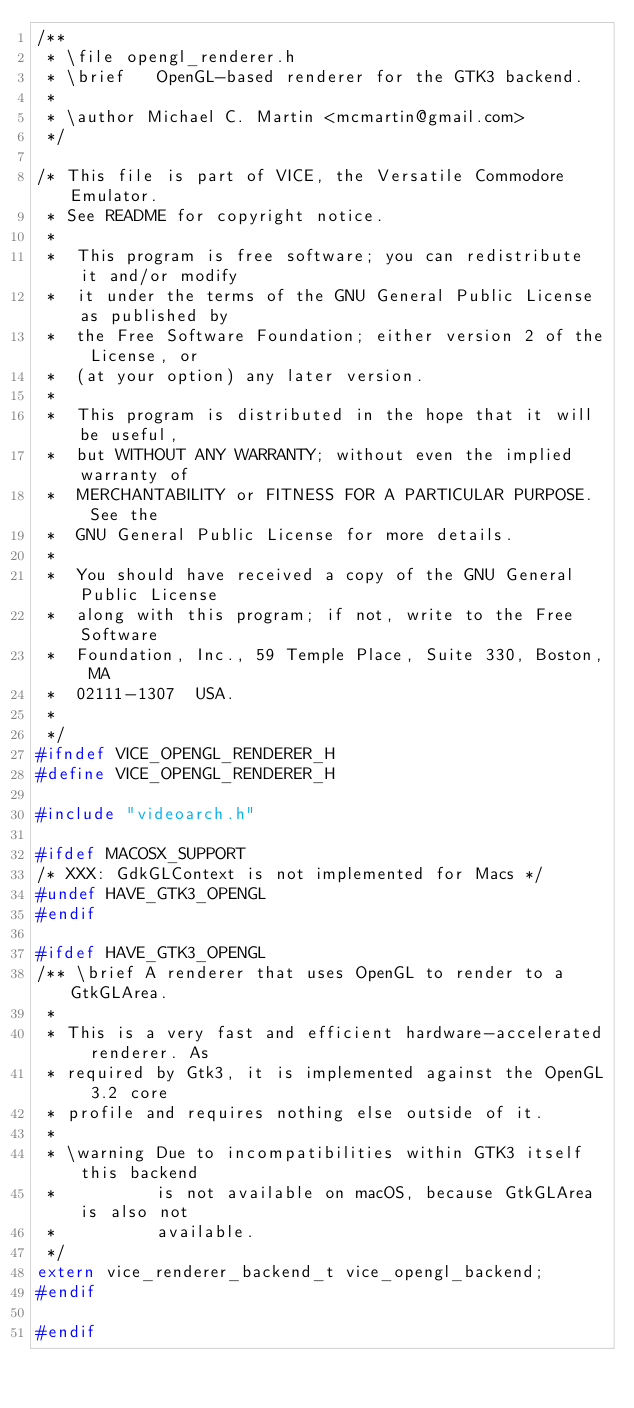<code> <loc_0><loc_0><loc_500><loc_500><_C_>/**
 * \file opengl_renderer.h
 * \brief   OpenGL-based renderer for the GTK3 backend.
 *
 * \author Michael C. Martin <mcmartin@gmail.com>
 */

/* This file is part of VICE, the Versatile Commodore Emulator.
 * See README for copyright notice.
 *
 *  This program is free software; you can redistribute it and/or modify
 *  it under the terms of the GNU General Public License as published by
 *  the Free Software Foundation; either version 2 of the License, or
 *  (at your option) any later version.
 *
 *  This program is distributed in the hope that it will be useful,
 *  but WITHOUT ANY WARRANTY; without even the implied warranty of
 *  MERCHANTABILITY or FITNESS FOR A PARTICULAR PURPOSE.  See the
 *  GNU General Public License for more details.
 *
 *  You should have received a copy of the GNU General Public License
 *  along with this program; if not, write to the Free Software
 *  Foundation, Inc., 59 Temple Place, Suite 330, Boston, MA
 *  02111-1307  USA.
 *
 */
#ifndef VICE_OPENGL_RENDERER_H
#define VICE_OPENGL_RENDERER_H

#include "videoarch.h"

#ifdef MACOSX_SUPPORT
/* XXX: GdkGLContext is not implemented for Macs */
#undef HAVE_GTK3_OPENGL
#endif

#ifdef HAVE_GTK3_OPENGL
/** \brief A renderer that uses OpenGL to render to a GtkGLArea.
 *
 * This is a very fast and efficient hardware-accelerated renderer. As
 * required by Gtk3, it is implemented against the OpenGL 3.2 core
 * profile and requires nothing else outside of it.
 *
 * \warning Due to incompatibilities within GTK3 itself this backend
 *          is not available on macOS, because GtkGLArea is also not
 *          available.
 */
extern vice_renderer_backend_t vice_opengl_backend;
#endif

#endif
</code> 